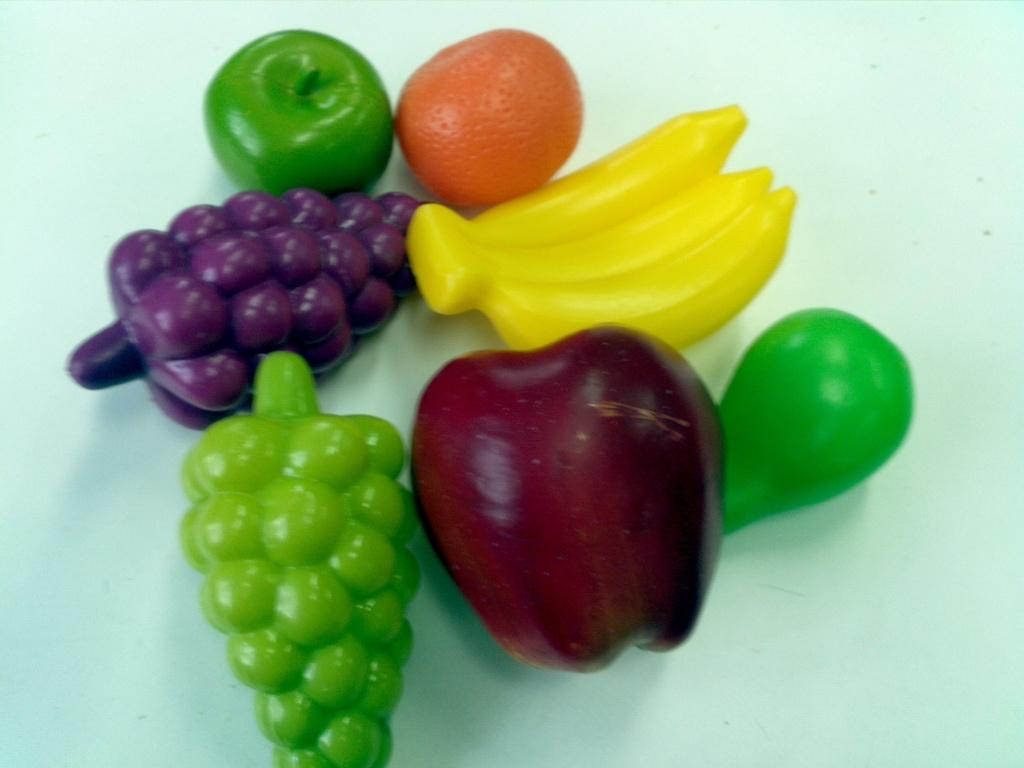What type of plastic fruits are present in the image? There are plastic grapes, bananas, apples, and oranges in the image. Can you describe any other plastic items in the image? There are other unspecified plastic items in the image. What is your opinion on the pies in the image? There are no pies present in the image, so it is not possible to provide an opinion on them. 